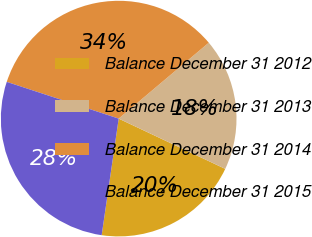Convert chart. <chart><loc_0><loc_0><loc_500><loc_500><pie_chart><fcel>Balance December 31 2012<fcel>Balance December 31 2013<fcel>Balance December 31 2014<fcel>Balance December 31 2015<nl><fcel>20.29%<fcel>18.16%<fcel>33.81%<fcel>27.74%<nl></chart> 